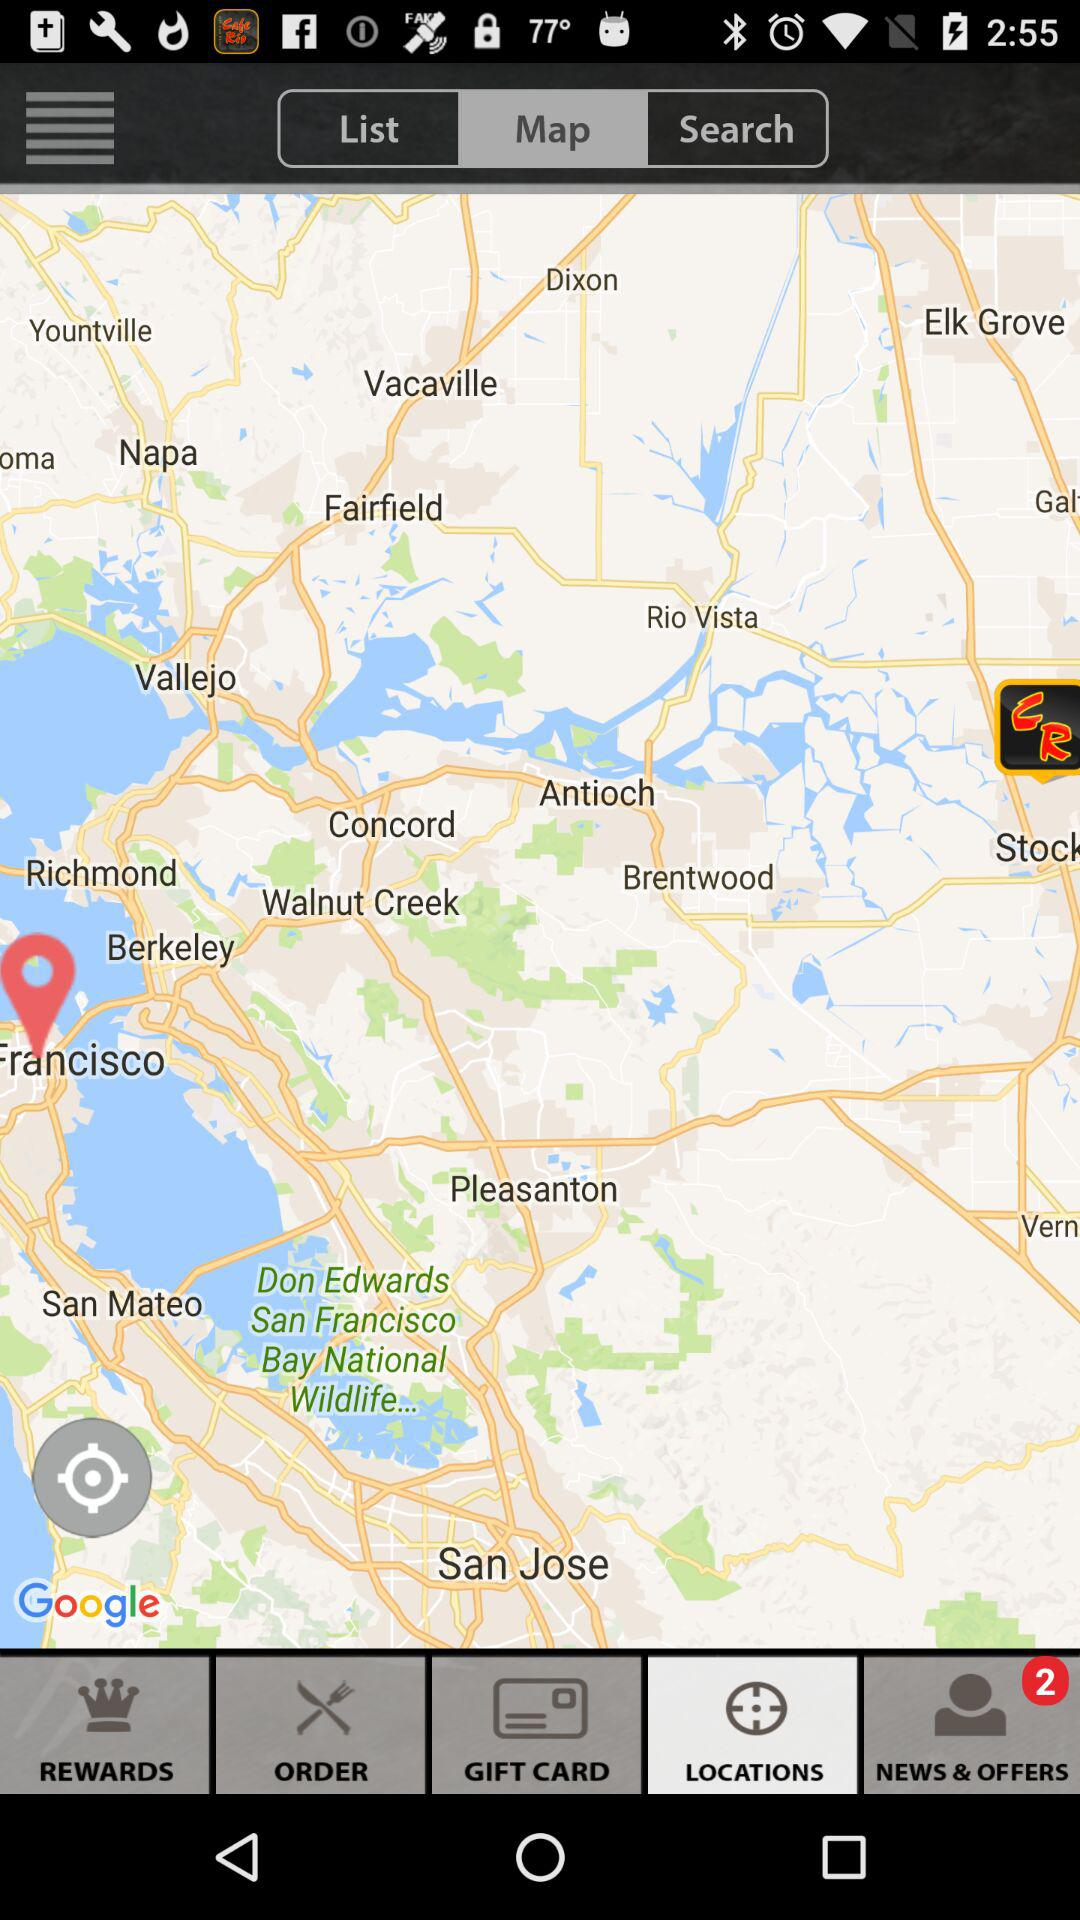Which option is selected? The selected options are "Map" and "LOCATIONS". 